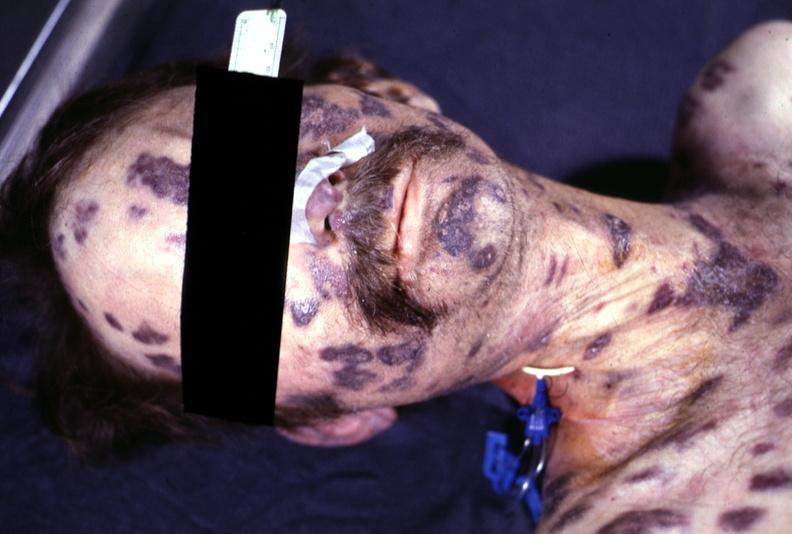what does this image show?
Answer the question using a single word or phrase. Skin 